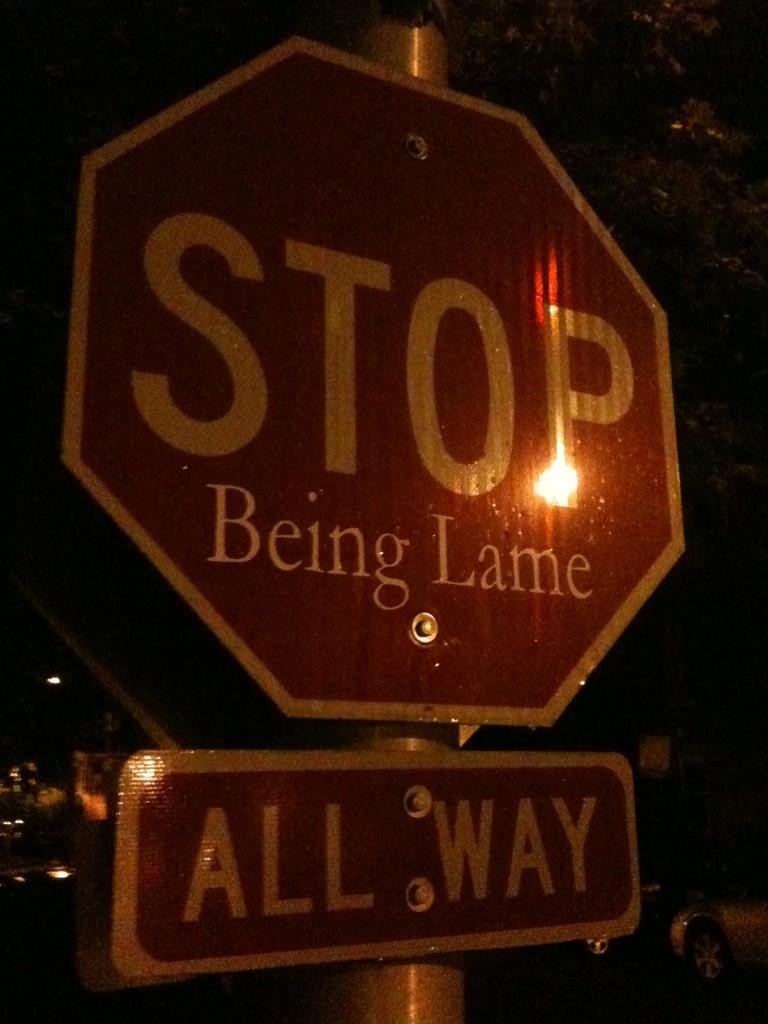What text was added to this stop sign?
Provide a short and direct response. Being lame. What does the sign say?
Ensure brevity in your answer.  Stop being lame. 